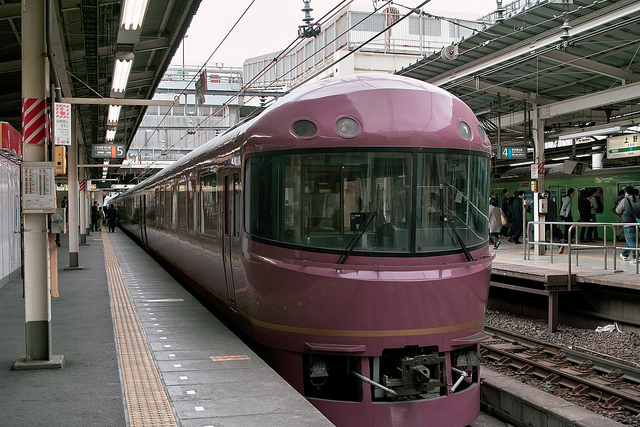Read and extract the text from this image. 5 4 